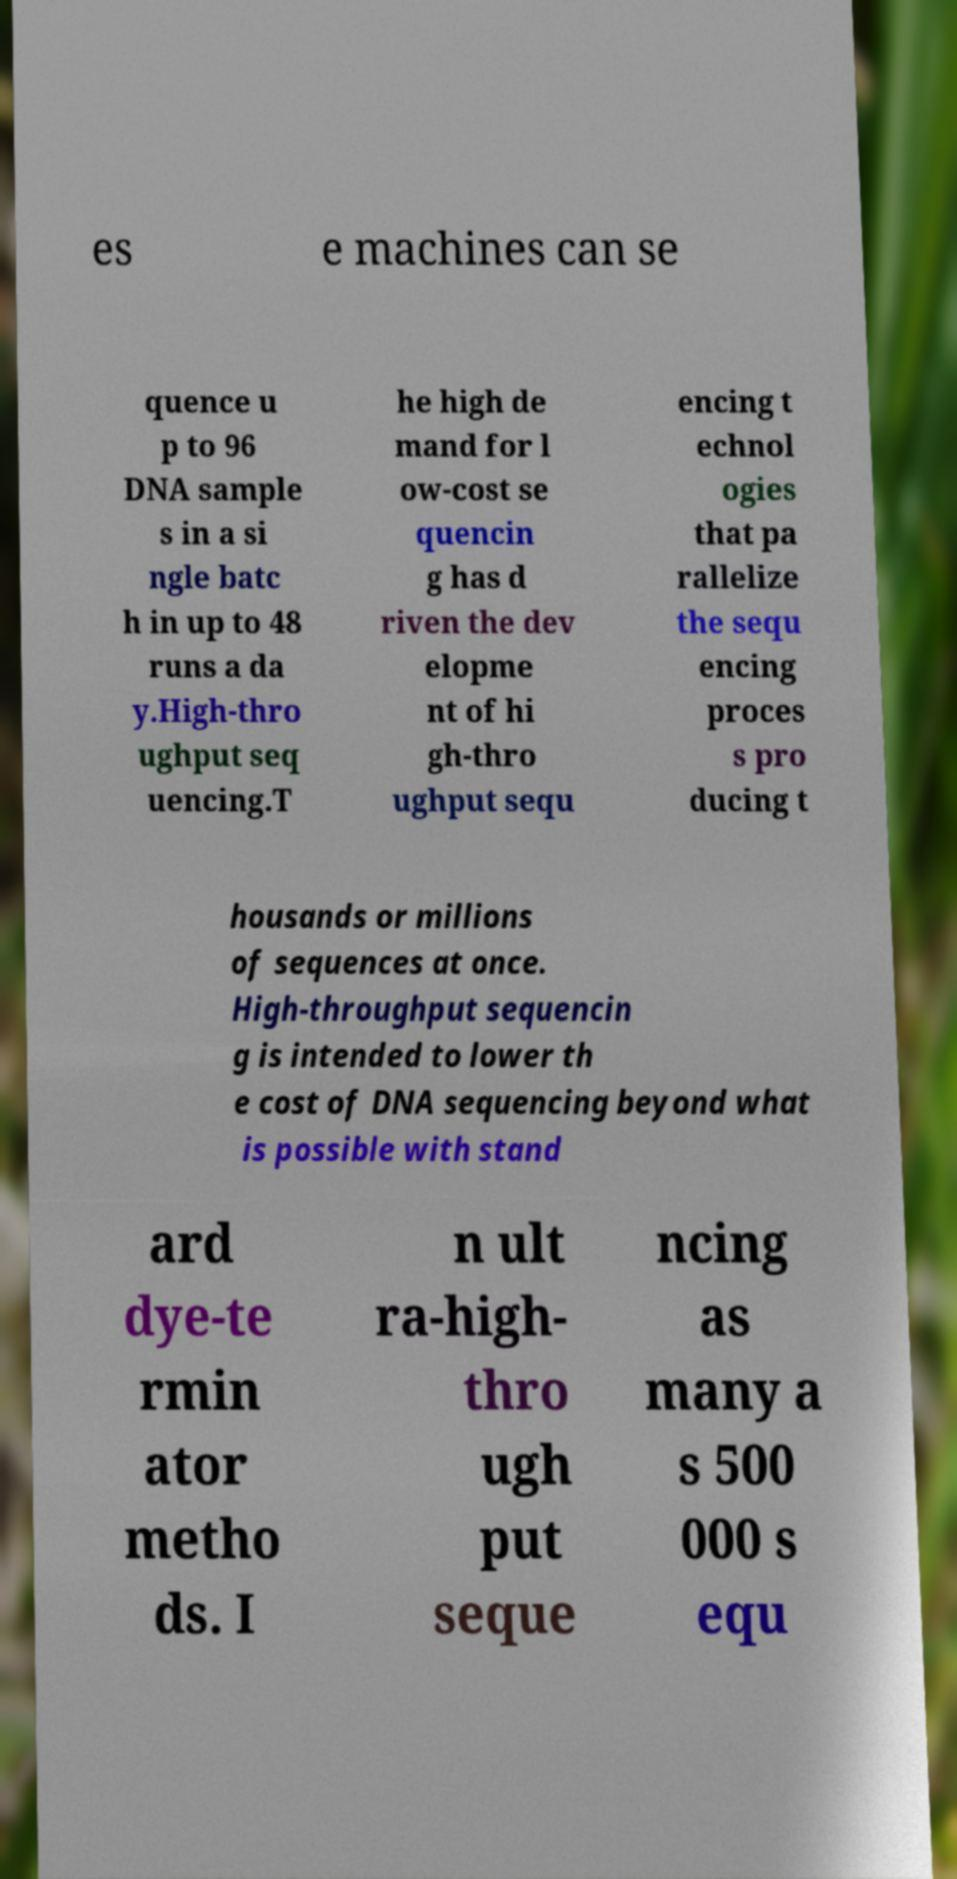I need the written content from this picture converted into text. Can you do that? es e machines can se quence u p to 96 DNA sample s in a si ngle batc h in up to 48 runs a da y.High-thro ughput seq uencing.T he high de mand for l ow-cost se quencin g has d riven the dev elopme nt of hi gh-thro ughput sequ encing t echnol ogies that pa rallelize the sequ encing proces s pro ducing t housands or millions of sequences at once. High-throughput sequencin g is intended to lower th e cost of DNA sequencing beyond what is possible with stand ard dye-te rmin ator metho ds. I n ult ra-high- thro ugh put seque ncing as many a s 500 000 s equ 